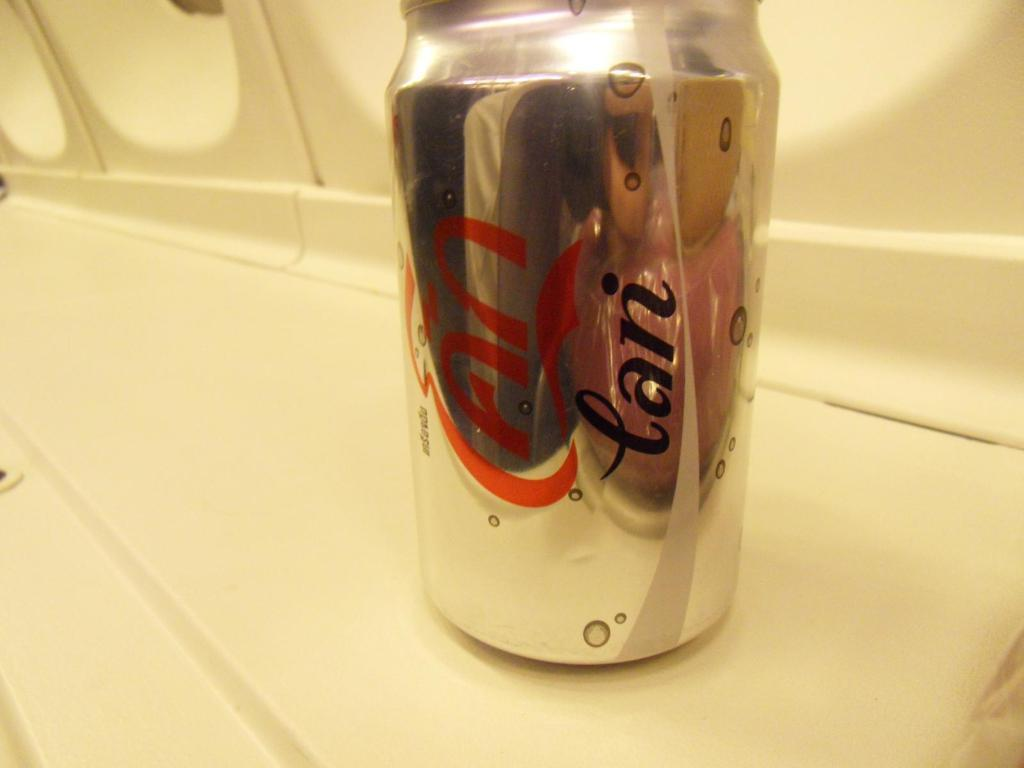<image>
Summarize the visual content of the image. A canned beverage says "lan" on it in black text. 